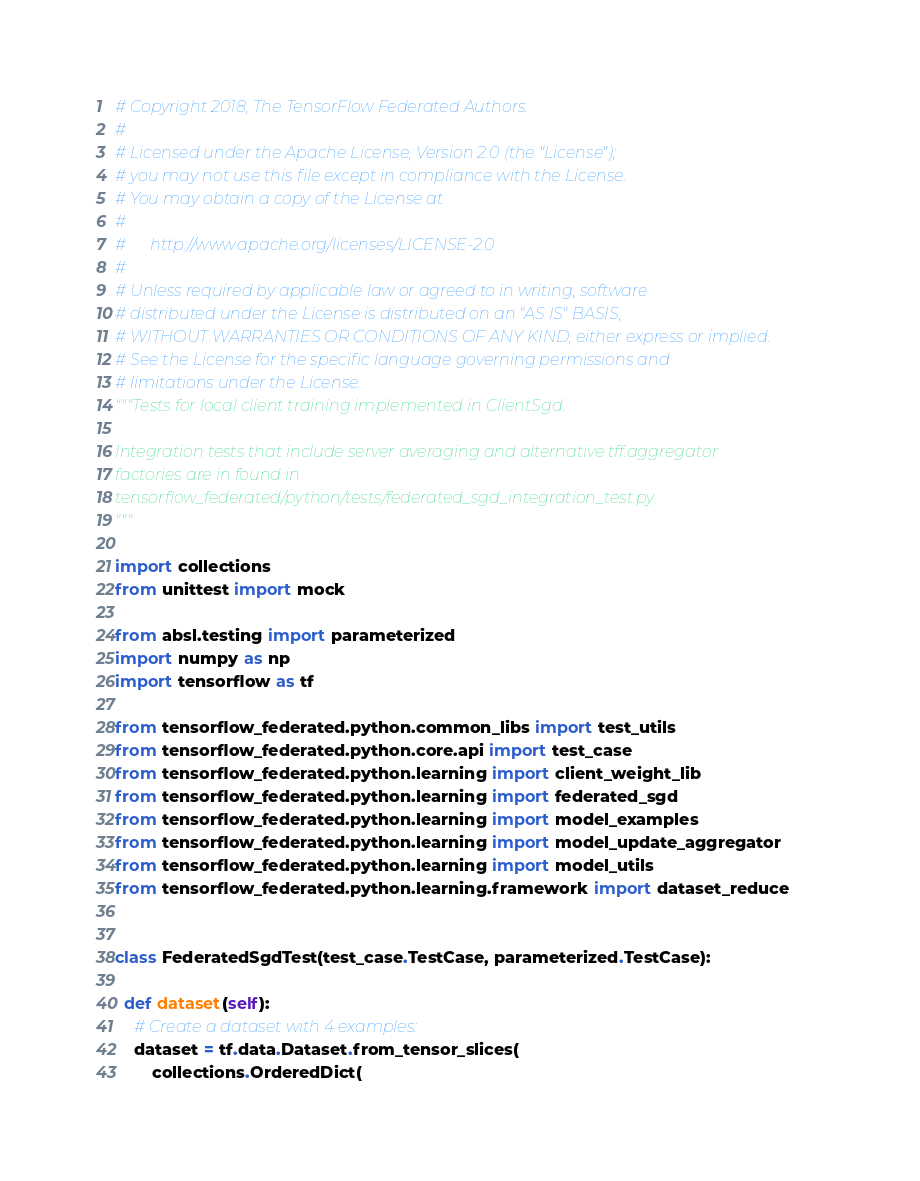Convert code to text. <code><loc_0><loc_0><loc_500><loc_500><_Python_># Copyright 2018, The TensorFlow Federated Authors.
#
# Licensed under the Apache License, Version 2.0 (the "License");
# you may not use this file except in compliance with the License.
# You may obtain a copy of the License at
#
#      http://www.apache.org/licenses/LICENSE-2.0
#
# Unless required by applicable law or agreed to in writing, software
# distributed under the License is distributed on an "AS IS" BASIS,
# WITHOUT WARRANTIES OR CONDITIONS OF ANY KIND, either express or implied.
# See the License for the specific language governing permissions and
# limitations under the License.
"""Tests for local client training implemented in ClientSgd.

Integration tests that include server averaging and alternative tff.aggregator
factories are in found in
tensorflow_federated/python/tests/federated_sgd_integration_test.py.
"""

import collections
from unittest import mock

from absl.testing import parameterized
import numpy as np
import tensorflow as tf

from tensorflow_federated.python.common_libs import test_utils
from tensorflow_federated.python.core.api import test_case
from tensorflow_federated.python.learning import client_weight_lib
from tensorflow_federated.python.learning import federated_sgd
from tensorflow_federated.python.learning import model_examples
from tensorflow_federated.python.learning import model_update_aggregator
from tensorflow_federated.python.learning import model_utils
from tensorflow_federated.python.learning.framework import dataset_reduce


class FederatedSgdTest(test_case.TestCase, parameterized.TestCase):

  def dataset(self):
    # Create a dataset with 4 examples:
    dataset = tf.data.Dataset.from_tensor_slices(
        collections.OrderedDict(</code> 